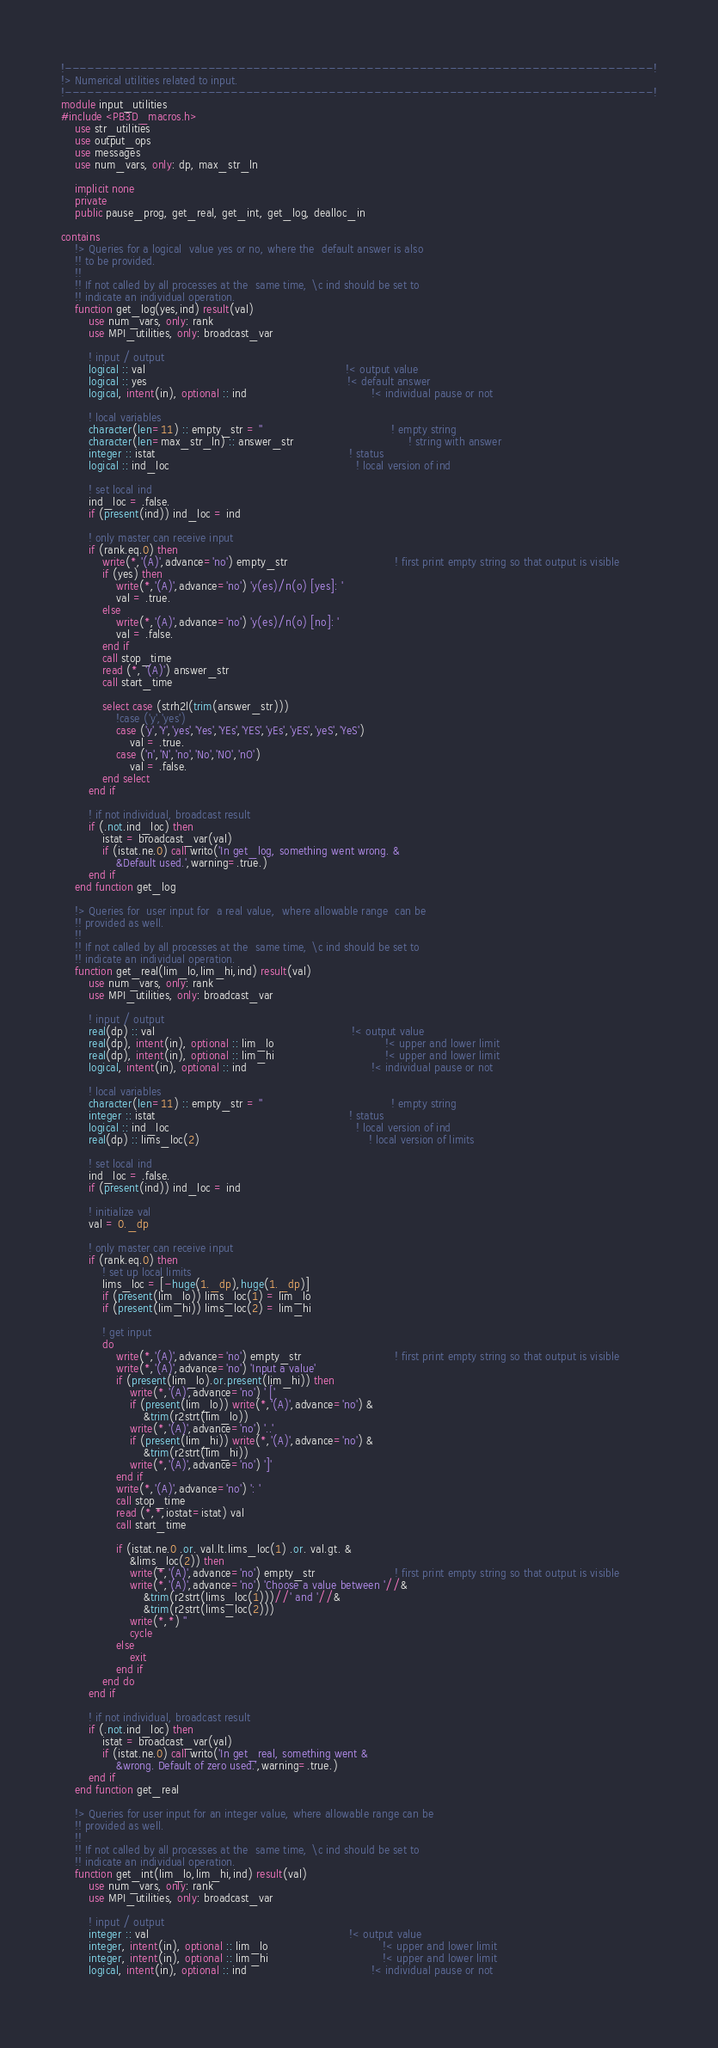<code> <loc_0><loc_0><loc_500><loc_500><_FORTRAN_>!------------------------------------------------------------------------------!
!> Numerical utilities related to input.
!------------------------------------------------------------------------------!
module input_utilities
#include <PB3D_macros.h>
    use str_utilities
    use output_ops
    use messages
    use num_vars, only: dp, max_str_ln
    
    implicit none
    private
    public pause_prog, get_real, get_int, get_log, dealloc_in
    
contains
    !> Queries for a logical  value yes or no, where the  default answer is also
    !! to be provided.
    !! 
    !! If not called by all processes at the  same time, \c ind should be set to
    !! indicate an individual operation.
    function get_log(yes,ind) result(val)
        use num_vars, only: rank
        use MPI_utilities, only: broadcast_var
        
        ! input / output
        logical :: val                                                          !< output value
        logical :: yes                                                          !< default answer
        logical, intent(in), optional :: ind                                    !< individual pause or not
        
        ! local variables
        character(len=11) :: empty_str = ''                                     ! empty string
        character(len=max_str_ln) :: answer_str                                 ! string with answer
        integer :: istat                                                        ! status
        logical :: ind_loc                                                      ! local version of ind
        
        ! set local ind
        ind_loc = .false.
        if (present(ind)) ind_loc = ind
        
        ! only master can receive input
        if (rank.eq.0) then
            write(*,'(A)',advance='no') empty_str                               ! first print empty string so that output is visible
            if (yes) then
                write(*,'(A)',advance='no') 'y(es)/n(o) [yes]: '
                val = .true.
            else
                write(*,'(A)',advance='no') 'y(es)/n(o) [no]: '
                val = .false.
            end if
            call stop_time
            read (*, '(A)') answer_str
            call start_time
            
            select case (strh2l(trim(answer_str)))
                !case ('y','yes')
                case ('y','Y','yes','Yes','YEs','YES','yEs','yES','yeS','YeS')
                    val = .true.
                case ('n','N','no','No','NO','nO') 
                    val = .false.
            end select
        end if
        
        ! if not individual, broadcast result
        if (.not.ind_loc) then
            istat = broadcast_var(val)
            if (istat.ne.0) call writo('In get_log, something went wrong. &
                &Default used.',warning=.true.)
        end if
    end function get_log
    
    !> Queries for  user input for  a real value,  where allowable range  can be
    !! provided as well.
    !! 
    !! If not called by all processes at the  same time, \c ind should be set to
    !! indicate an individual operation.
    function get_real(lim_lo,lim_hi,ind) result(val)
        use num_vars, only: rank
        use MPI_utilities, only: broadcast_var
        
        ! input / output
        real(dp) :: val                                                         !< output value
        real(dp), intent(in), optional :: lim_lo                                !< upper and lower limit
        real(dp), intent(in), optional :: lim_hi                                !< upper and lower limit
        logical, intent(in), optional :: ind                                    !< individual pause or not
        
        ! local variables
        character(len=11) :: empty_str = ''                                     ! empty string
        integer :: istat                                                        ! status
        logical :: ind_loc                                                      ! local version of ind
        real(dp) :: lims_loc(2)                                                 ! local version of limits
        
        ! set local ind
        ind_loc = .false.
        if (present(ind)) ind_loc = ind
        
        ! initialize val
        val = 0._dp
        
        ! only master can receive input
        if (rank.eq.0) then
            ! set up local limits
            lims_loc = [-huge(1._dp),huge(1._dp)]
            if (present(lim_lo)) lims_loc(1) = lim_lo
            if (present(lim_hi)) lims_loc(2) = lim_hi
            
            ! get input
            do
                write(*,'(A)',advance='no') empty_str                           ! first print empty string so that output is visible
                write(*,'(A)',advance='no') 'Input a value'
                if (present(lim_lo).or.present(lim_hi)) then
                    write(*,'(A)',advance='no') ' ['
                    if (present(lim_lo)) write(*,'(A)',advance='no') &
                        &trim(r2strt(lim_lo))
                    write(*,'(A)',advance='no') '..'
                    if (present(lim_hi)) write(*,'(A)',advance='no') &
                        &trim(r2strt(lim_hi))
                    write(*,'(A)',advance='no') ']'
                end if
                write(*,'(A)',advance='no') ': '
                call stop_time
                read (*,*,iostat=istat) val
                call start_time
                
                if (istat.ne.0 .or. val.lt.lims_loc(1) .or. val.gt. &
                    &lims_loc(2)) then
                    write(*,'(A)',advance='no') empty_str                       ! first print empty string so that output is visible
                    write(*,'(A)',advance='no') 'Choose a value between '//&
                        &trim(r2strt(lims_loc(1)))//' and '//&
                        &trim(r2strt(lims_loc(2)))
                    write(*,*) ''
                    cycle
                else
                    exit
                end if
            end do
        end if
        
        ! if not individual, broadcast result
        if (.not.ind_loc) then
            istat = broadcast_var(val)
            if (istat.ne.0) call writo('In get_real, something went &
                &wrong. Default of zero used.',warning=.true.)
        end if
    end function get_real
    
    !> Queries for user input for an integer value, where allowable range can be
    !! provided as well.
    !! 
    !! If not called by all processes at the  same time, \c ind should be set to
    !! indicate an individual operation.
    function get_int(lim_lo,lim_hi,ind) result(val)
        use num_vars, only: rank
        use MPI_utilities, only: broadcast_var
        
        ! input / output
        integer :: val                                                          !< output value
        integer, intent(in), optional :: lim_lo                                 !< upper and lower limit
        integer, intent(in), optional :: lim_hi                                 !< upper and lower limit
        logical, intent(in), optional :: ind                                    !< individual pause or not
        </code> 